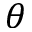Convert formula to latex. <formula><loc_0><loc_0><loc_500><loc_500>\theta</formula> 